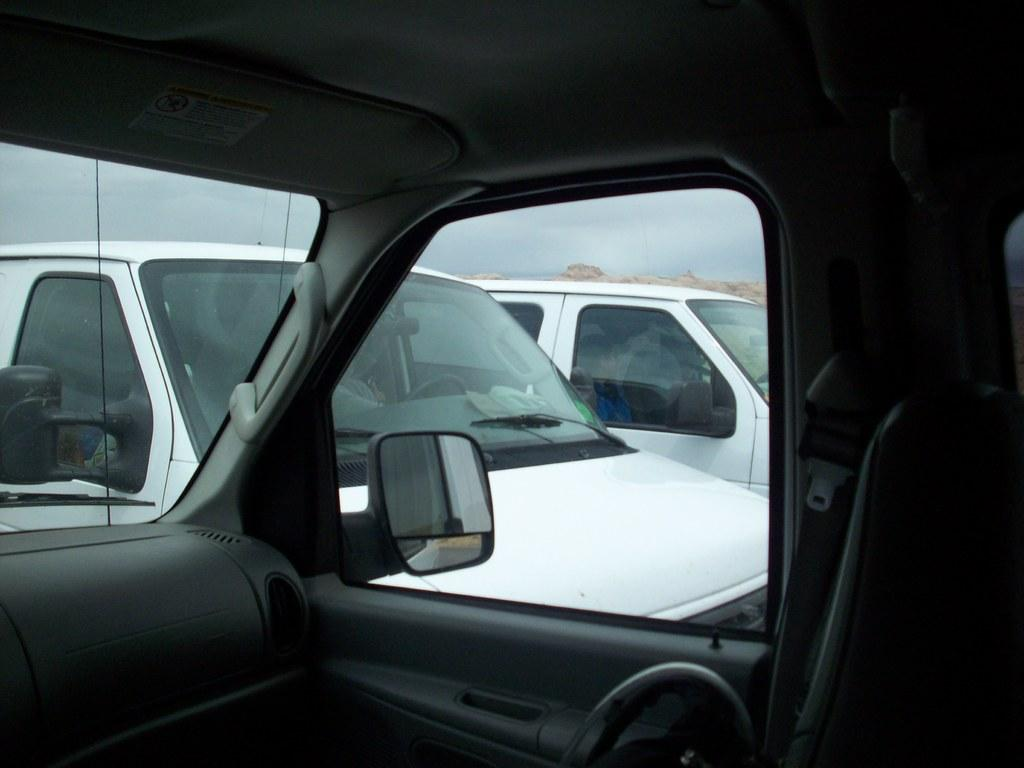What type of setting is shown in the image? The interior of a vehicle is visible in the image. What feature of the vehicle can be seen in the image? There is a window in the vehicle. What can be seen through the window? Two cars are visible from the window. What part of the vehicle is visible in the image? The windshield is visible in the image. How would you describe the weather based on the image? The sky is cloudy in the image. What rule is being enforced by the yard in the image? There is no yard present in the image, and therefore no rule can be enforced by it. 